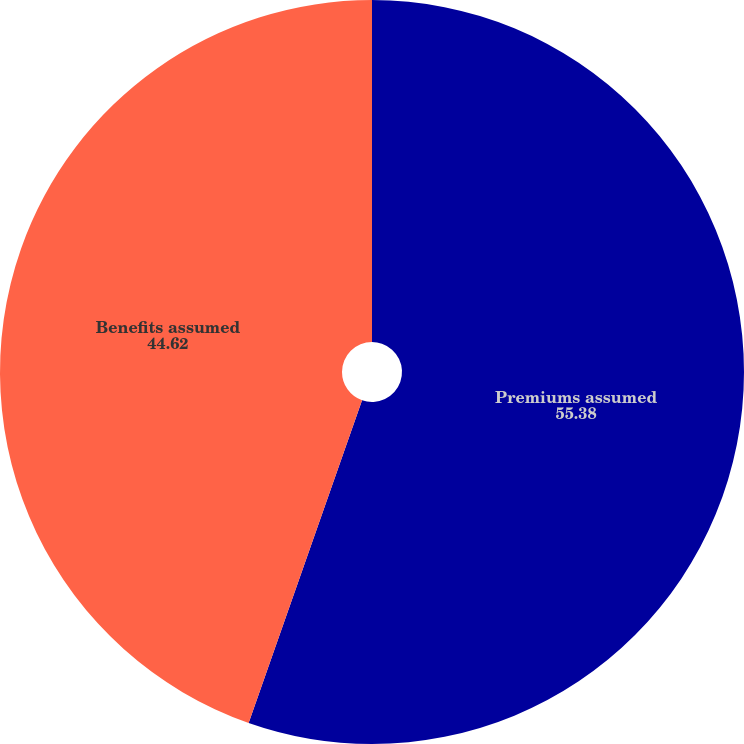<chart> <loc_0><loc_0><loc_500><loc_500><pie_chart><fcel>Premiums assumed<fcel>Benefits assumed<nl><fcel>55.38%<fcel>44.62%<nl></chart> 